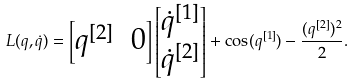Convert formula to latex. <formula><loc_0><loc_0><loc_500><loc_500>L ( q , \dot { q } ) = \begin{bmatrix} q ^ { [ 2 ] } & 0 \end{bmatrix} \begin{bmatrix} \dot { q } ^ { [ 1 ] } \\ \dot { q } ^ { [ 2 ] } \end{bmatrix} + \cos ( q ^ { [ 1 ] } ) - \frac { ( q ^ { [ 2 ] } ) ^ { 2 } } { 2 } .</formula> 